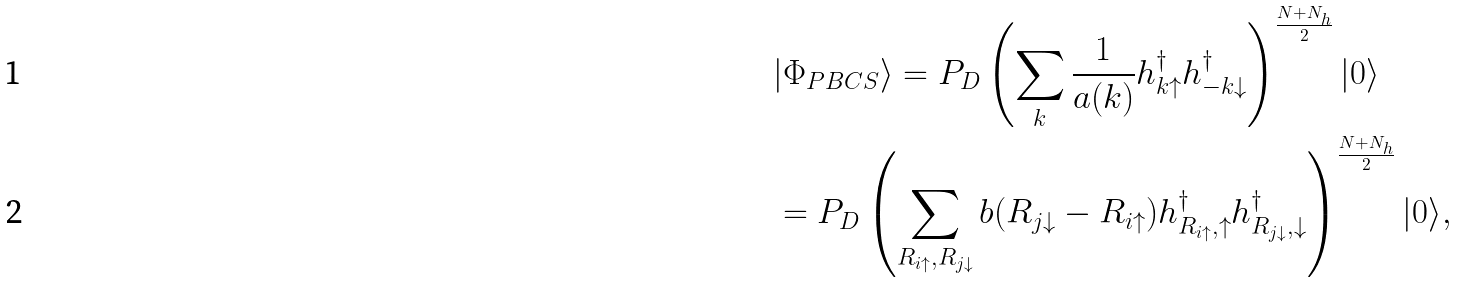<formula> <loc_0><loc_0><loc_500><loc_500>& | \Phi _ { P B C S } \rangle = P _ { D } \left ( \sum _ { k } \frac { 1 } { a ( k ) } h _ { k \uparrow } ^ { \dagger } h _ { - k \downarrow } ^ { \dagger } \right ) ^ { \frac { N + N _ { h } } { 2 } } | 0 \rangle \\ & = P _ { D } \left ( \sum _ { R _ { i \uparrow } , R _ { j \downarrow } } b ( R _ { j \downarrow } - R _ { i \uparrow } ) h _ { R _ { i \uparrow } , \uparrow } ^ { \dagger } h _ { R _ { j \downarrow } , \downarrow } ^ { \dagger } \right ) ^ { \frac { N + N _ { h } } { 2 } } | 0 \rangle ,</formula> 